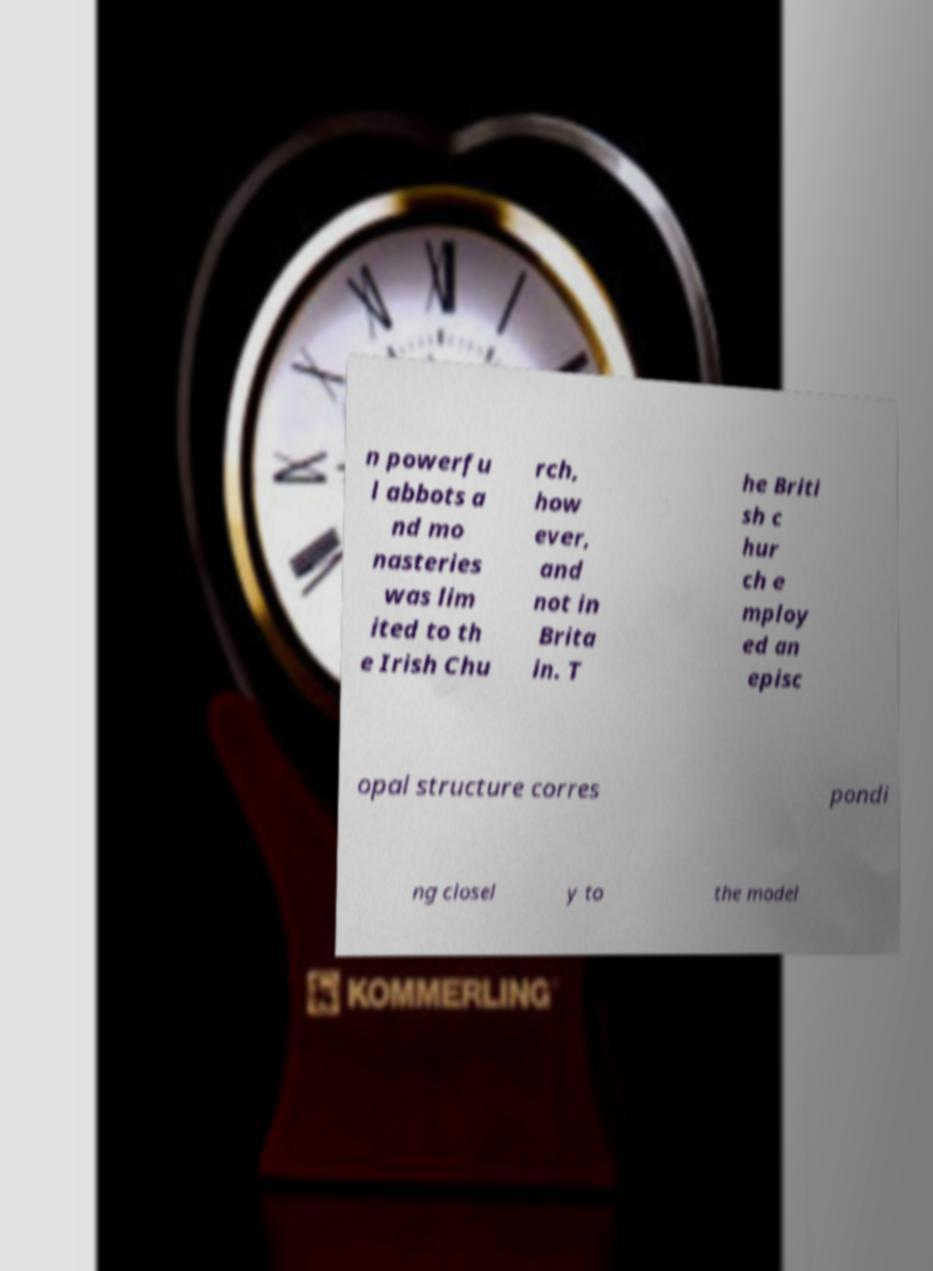There's text embedded in this image that I need extracted. Can you transcribe it verbatim? n powerfu l abbots a nd mo nasteries was lim ited to th e Irish Chu rch, how ever, and not in Brita in. T he Briti sh c hur ch e mploy ed an episc opal structure corres pondi ng closel y to the model 